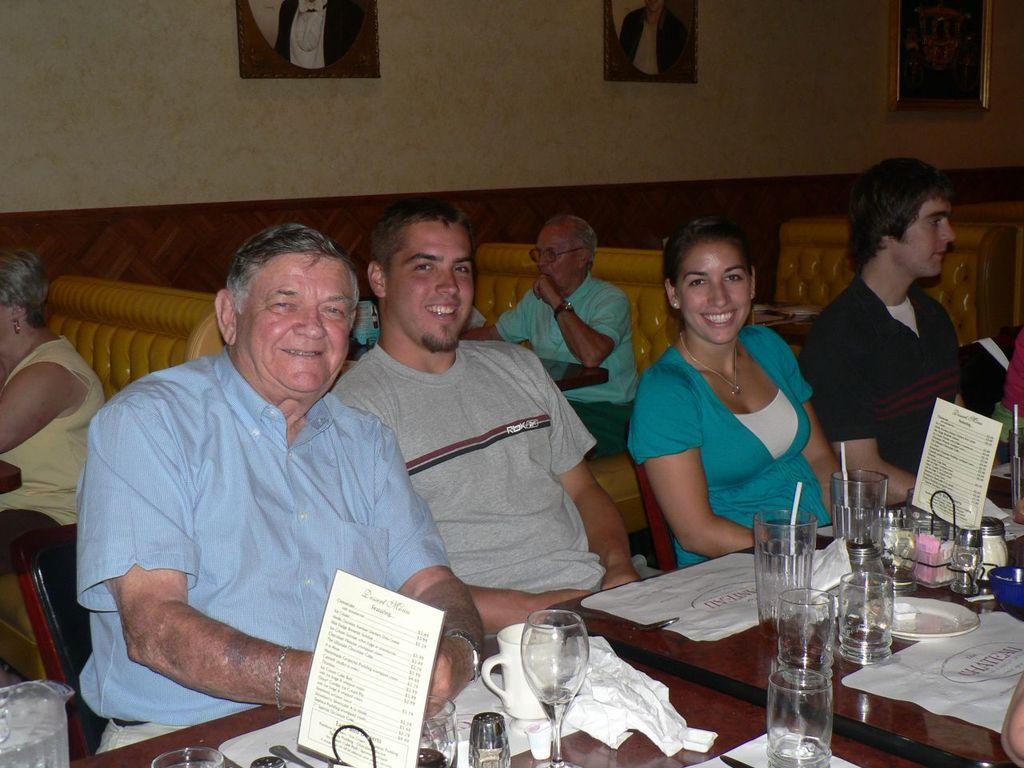Can you describe this image briefly? In this picture we can see a group of people where some are sitting on chairs and some are sitting on sofas and in front of them on tables we can see glasses, cup, tissue paper, jars, plate and in the background we can see frames on the wall. 